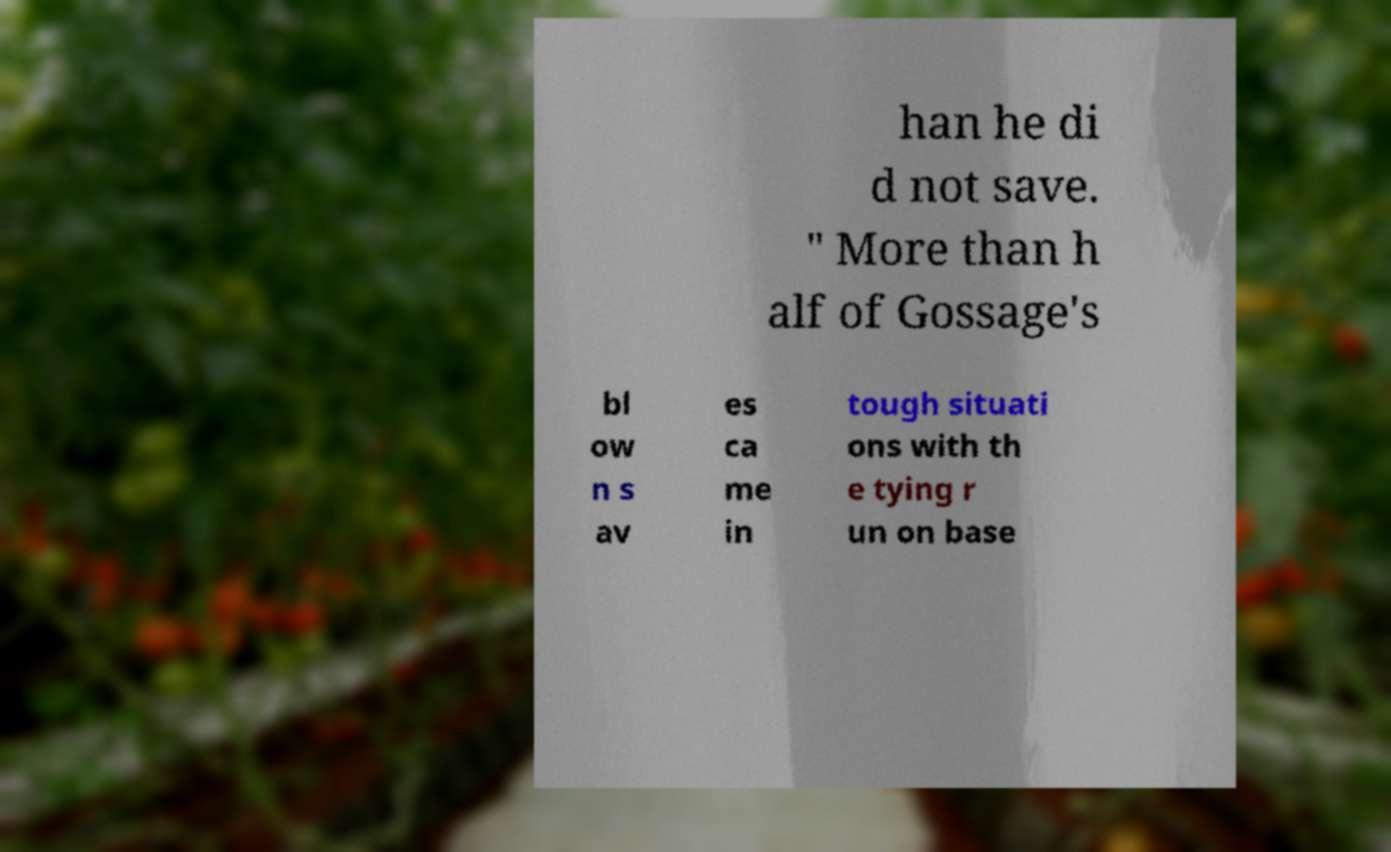Can you read and provide the text displayed in the image?This photo seems to have some interesting text. Can you extract and type it out for me? han he di d not save. " More than h alf of Gossage's bl ow n s av es ca me in tough situati ons with th e tying r un on base 